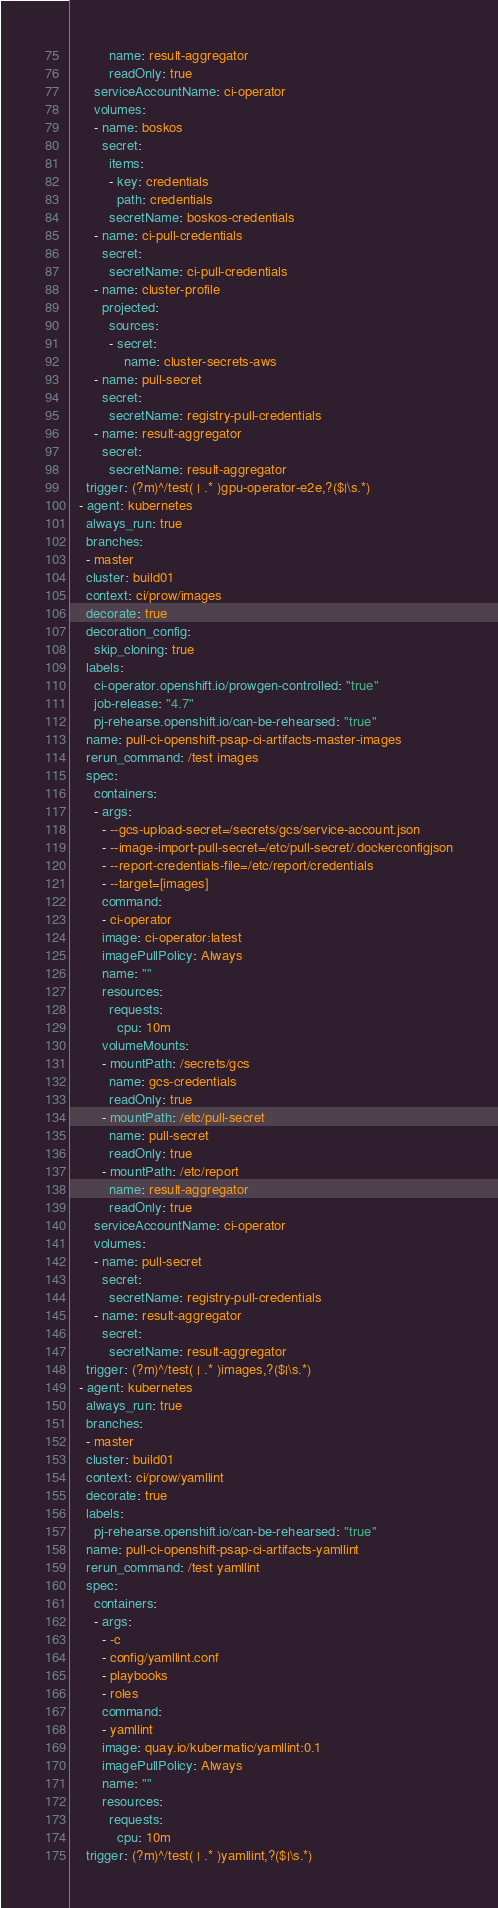Convert code to text. <code><loc_0><loc_0><loc_500><loc_500><_YAML_>          name: result-aggregator
          readOnly: true
      serviceAccountName: ci-operator
      volumes:
      - name: boskos
        secret:
          items:
          - key: credentials
            path: credentials
          secretName: boskos-credentials
      - name: ci-pull-credentials
        secret:
          secretName: ci-pull-credentials
      - name: cluster-profile
        projected:
          sources:
          - secret:
              name: cluster-secrets-aws
      - name: pull-secret
        secret:
          secretName: registry-pull-credentials
      - name: result-aggregator
        secret:
          secretName: result-aggregator
    trigger: (?m)^/test( | .* )gpu-operator-e2e,?($|\s.*)
  - agent: kubernetes
    always_run: true
    branches:
    - master
    cluster: build01
    context: ci/prow/images
    decorate: true
    decoration_config:
      skip_cloning: true
    labels:
      ci-operator.openshift.io/prowgen-controlled: "true"
      job-release: "4.7"
      pj-rehearse.openshift.io/can-be-rehearsed: "true"
    name: pull-ci-openshift-psap-ci-artifacts-master-images
    rerun_command: /test images
    spec:
      containers:
      - args:
        - --gcs-upload-secret=/secrets/gcs/service-account.json
        - --image-import-pull-secret=/etc/pull-secret/.dockerconfigjson
        - --report-credentials-file=/etc/report/credentials
        - --target=[images]
        command:
        - ci-operator
        image: ci-operator:latest
        imagePullPolicy: Always
        name: ""
        resources:
          requests:
            cpu: 10m
        volumeMounts:
        - mountPath: /secrets/gcs
          name: gcs-credentials
          readOnly: true
        - mountPath: /etc/pull-secret
          name: pull-secret
          readOnly: true
        - mountPath: /etc/report
          name: result-aggregator
          readOnly: true
      serviceAccountName: ci-operator
      volumes:
      - name: pull-secret
        secret:
          secretName: registry-pull-credentials
      - name: result-aggregator
        secret:
          secretName: result-aggregator
    trigger: (?m)^/test( | .* )images,?($|\s.*)
  - agent: kubernetes
    always_run: true
    branches:
    - master
    cluster: build01
    context: ci/prow/yamllint
    decorate: true
    labels:
      pj-rehearse.openshift.io/can-be-rehearsed: "true"
    name: pull-ci-openshift-psap-ci-artifacts-yamllint
    rerun_command: /test yamllint
    spec:
      containers:
      - args:
        - -c
        - config/yamllint.conf
        - playbooks
        - roles
        command:
        - yamllint
        image: quay.io/kubermatic/yamllint:0.1
        imagePullPolicy: Always
        name: ""
        resources:
          requests:
            cpu: 10m
    trigger: (?m)^/test( | .* )yamllint,?($|\s.*)
</code> 